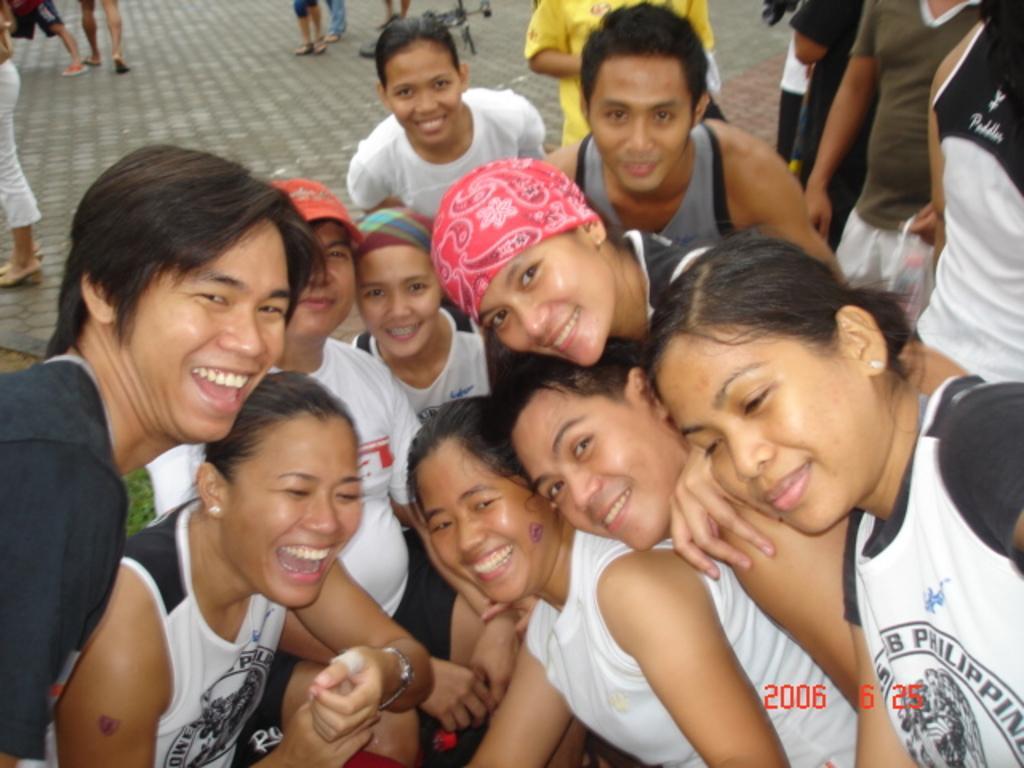Could you give a brief overview of what you see in this image? In this image there are few persons at the front side of image are smiling. Beside them there are few persons standing on the floor. Top of image few persons are walking and few persons are standing on the floor. There is a bicycle on the floor. 